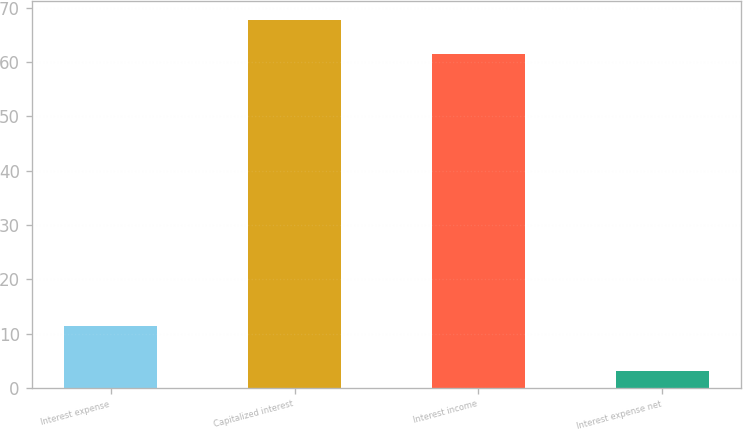<chart> <loc_0><loc_0><loc_500><loc_500><bar_chart><fcel>Interest expense<fcel>Capitalized interest<fcel>Interest income<fcel>Interest expense net<nl><fcel>11.4<fcel>67.86<fcel>61.5<fcel>3.1<nl></chart> 